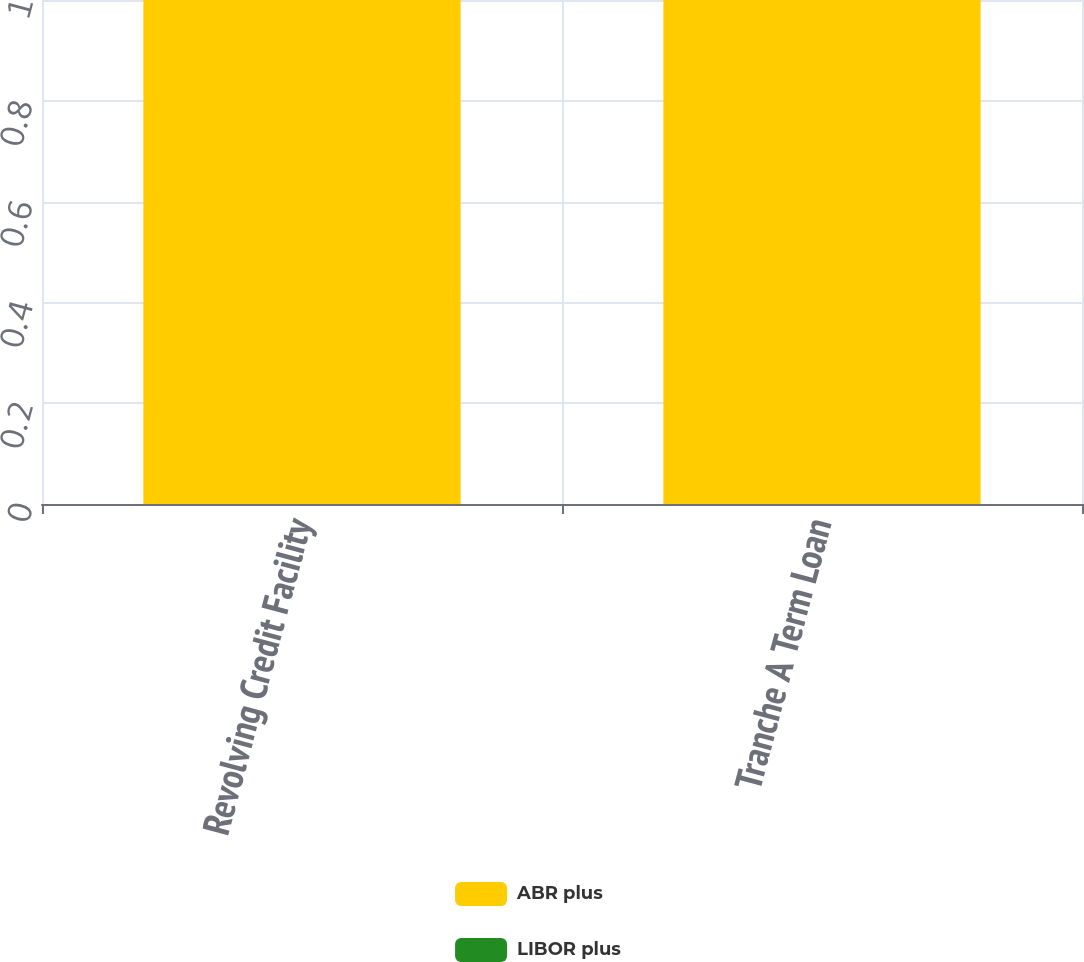Convert chart to OTSL. <chart><loc_0><loc_0><loc_500><loc_500><stacked_bar_chart><ecel><fcel>Revolving Credit Facility<fcel>Tranche A Term Loan<nl><fcel>ABR plus<fcel>1<fcel>1<nl><fcel>LIBOR plus<fcel>0<fcel>0<nl></chart> 